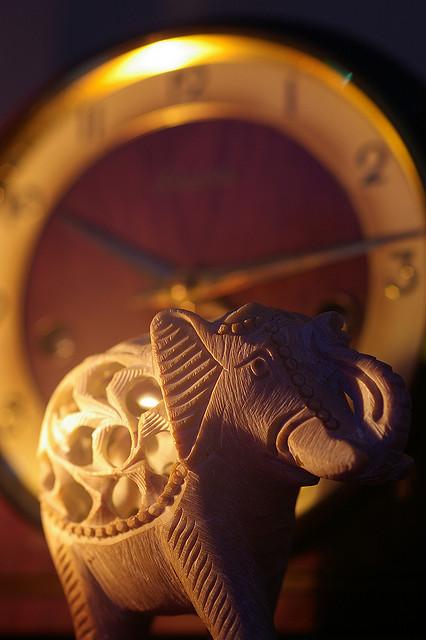What part of the animal is it holding up?
Be succinct. Trunk. What is in the background behind the elephant?
Write a very short answer. Clock. What is the animal?
Quick response, please. Elephant. 